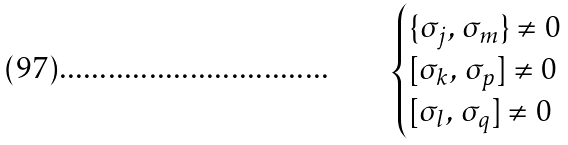<formula> <loc_0><loc_0><loc_500><loc_500>\begin{cases} \{ \sigma _ { j } , \, \sigma _ { m } \} \neq 0 \\ [ \sigma _ { k } , \, \sigma _ { p } ] \neq 0 \\ [ \sigma _ { l } , \, \sigma _ { q } ] \neq 0 \end{cases}</formula> 